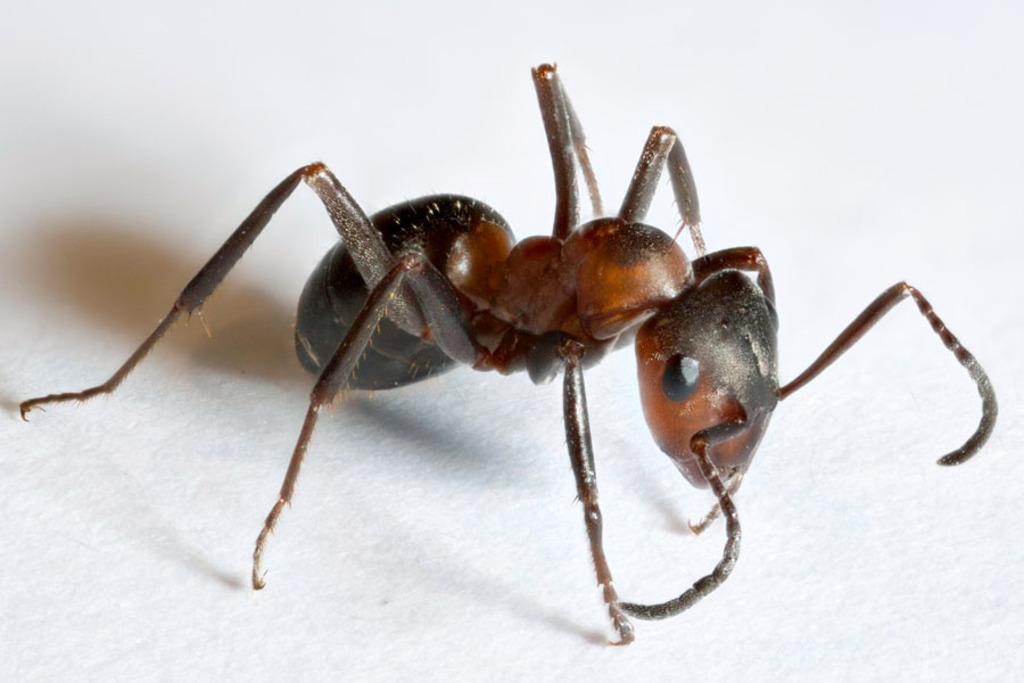What is the main subject of the image? The main subject of the image is an ant. What is the color of the surface the ant is on? The ant is on a white surface. What type of ear is visible in the image? There is no ear present in the image; it features an ant on a white surface. How does the bee react to the surprise in the image? There is no bee or surprise present in the image; it only features an ant on a white surface. 